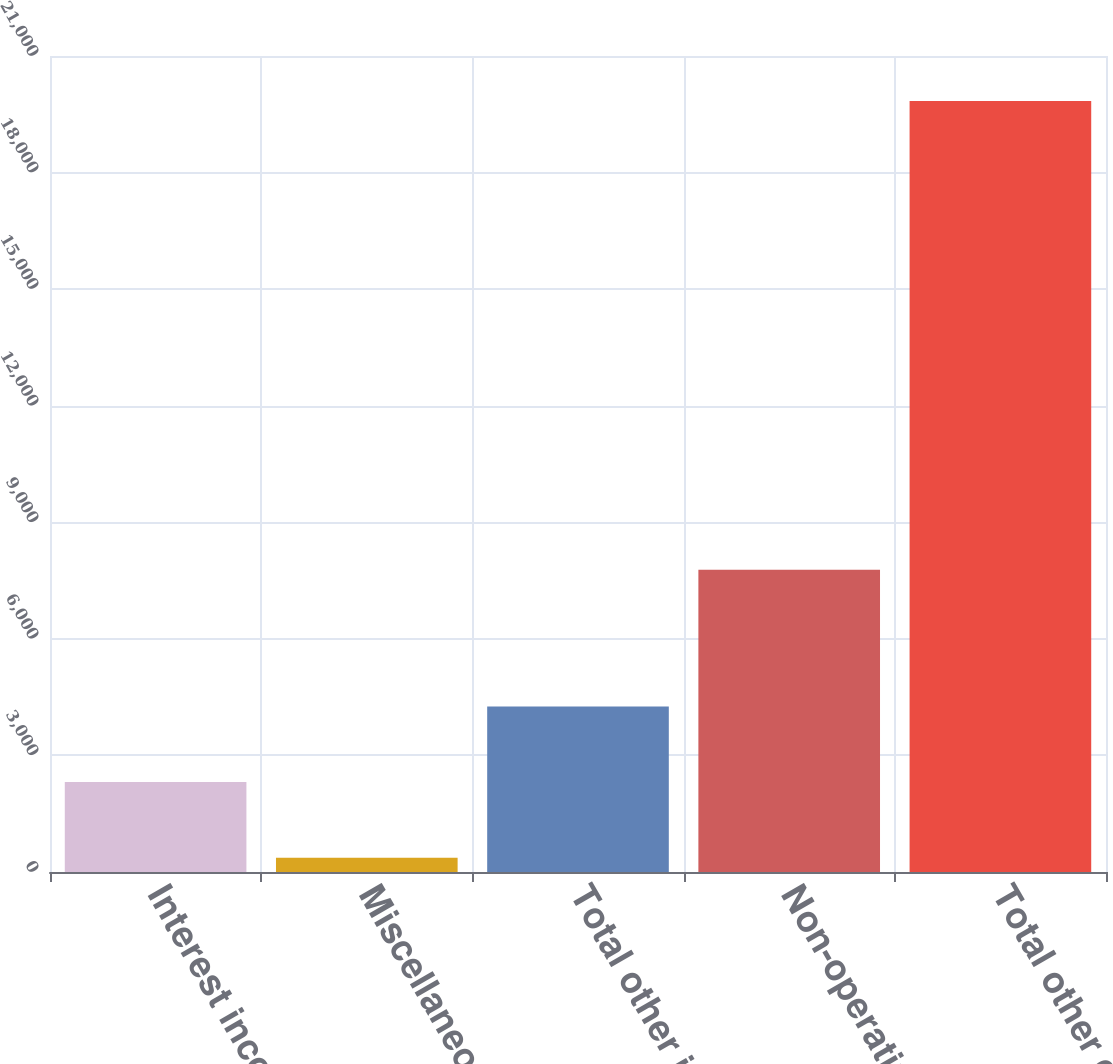Convert chart to OTSL. <chart><loc_0><loc_0><loc_500><loc_500><bar_chart><fcel>Interest income<fcel>Miscellaneous<fcel>Total other income<fcel>Non-operating costs<fcel>Total other expense<nl><fcel>2314.5<fcel>367<fcel>4262<fcel>7777<fcel>19842<nl></chart> 